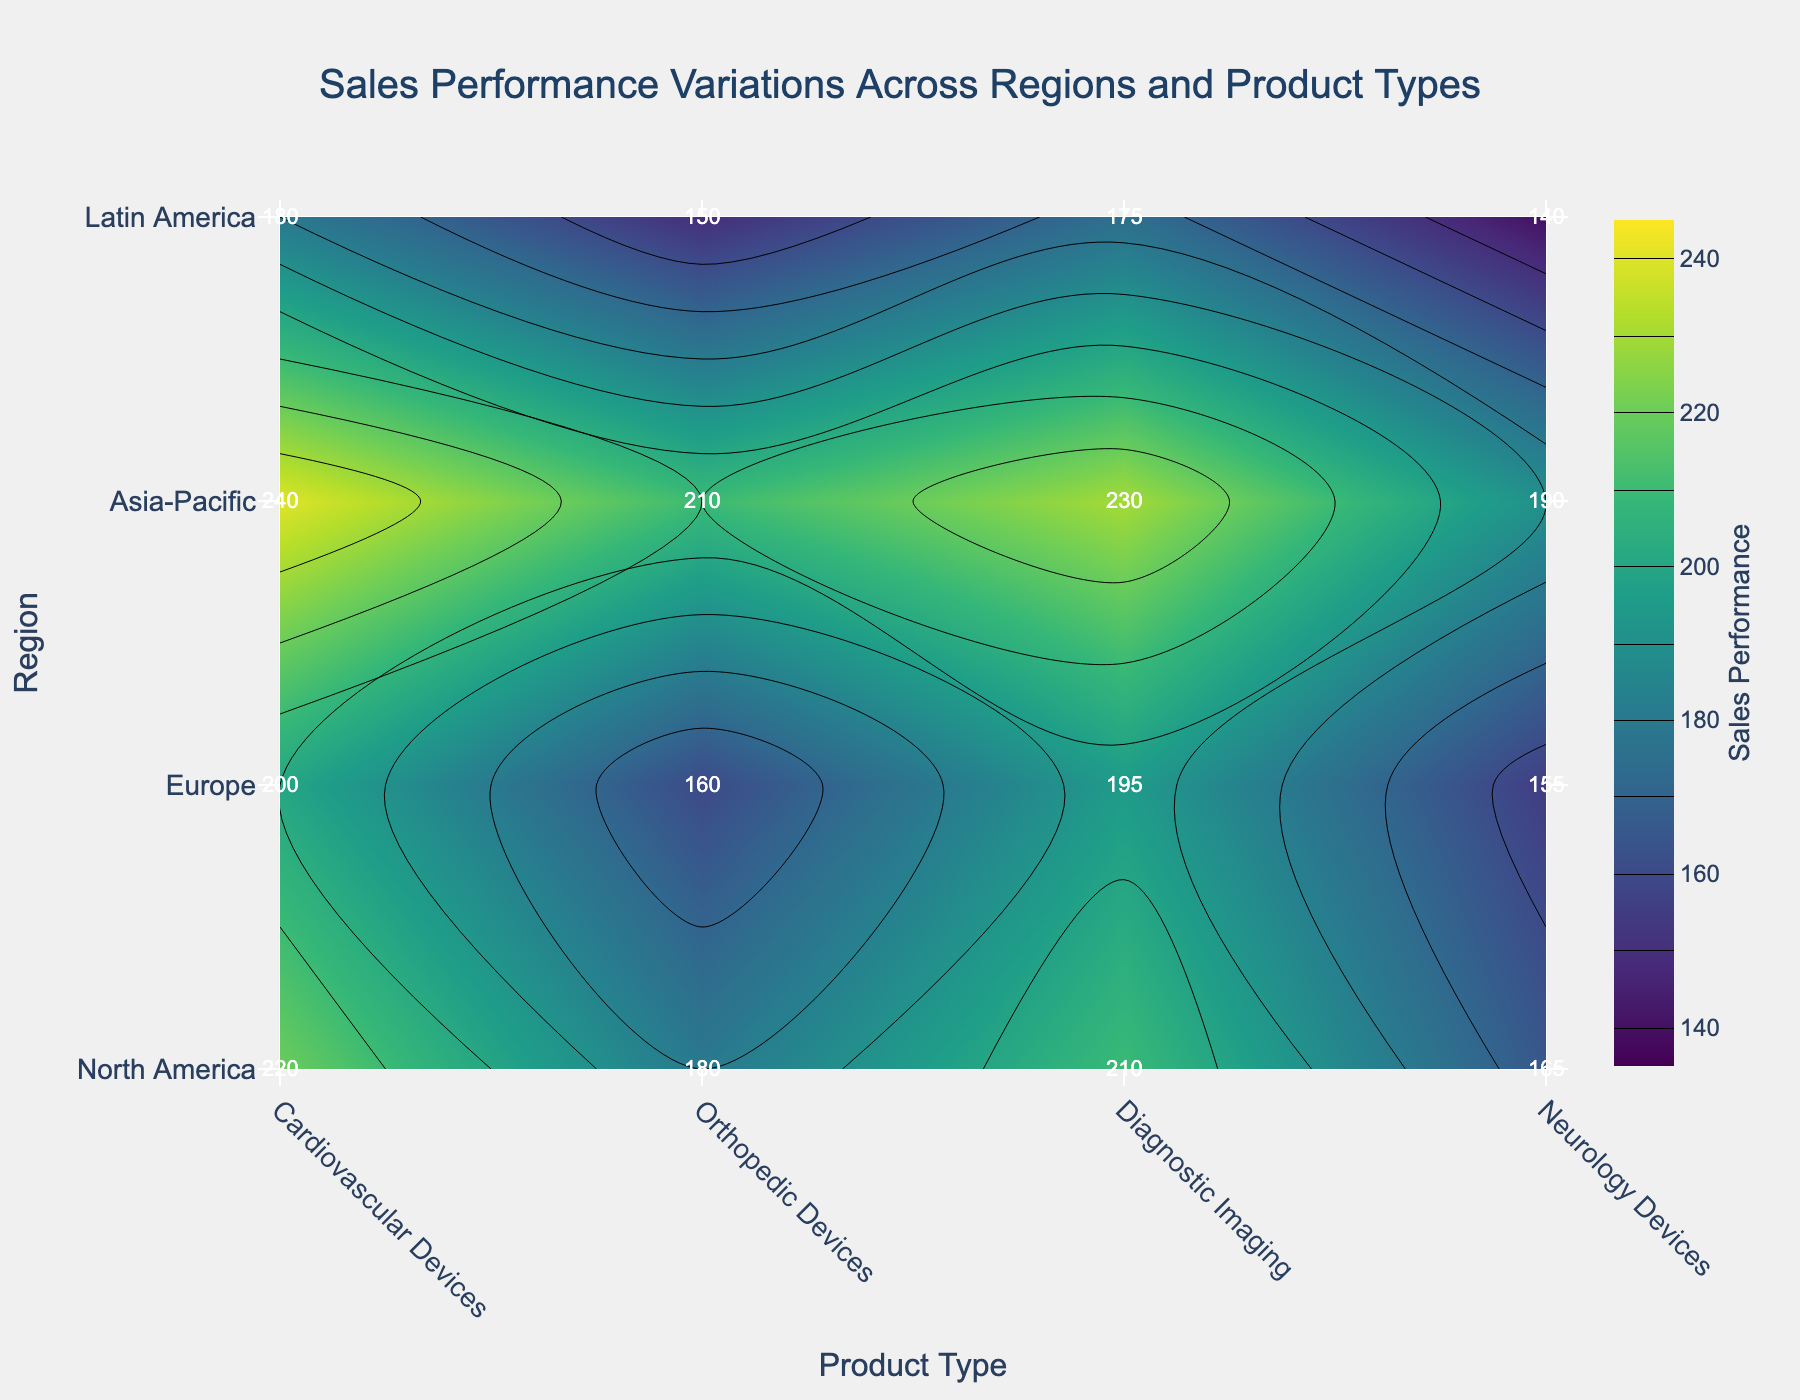What's the title of the figure? The title is usually displayed at the top of the plot. In this case, it's clearly shown as 'Sales Performance Variations Across Regions and Product Types'.
Answer: Sales Performance Variations Across Regions and Product Types Which product type in Asia-Pacific has the highest sales performance? Look for the region 'Asia-Pacific' on the y-axis and identify the product type with the highest value in that row. 'Cardiovascular Devices' shows a sales performance of 240, which is the highest in the 'Asia-Pacific' row.
Answer: Cardiovascular Devices What's the difference in sales performance between Neurology Devices in North America and Diagnostic Imaging in Europe? Identify the sales performance values: 'Neurology Devices' in 'North America' is 165 and 'Diagnostic Imaging' in 'Europe' is 195. The difference is 195 - 165.
Answer: 30 How many regions are evaluated in the figure? Count the number of unique entries in the 'Region' axis on the figure. The regions are 'North America', 'Europe', 'Asia-Pacific', and 'Latin America'.
Answer: 4 Which product type has the lowest sales performance in Latin America? Look for the region 'Latin America' and check the sales performance values for the product types in that row. 'Neurology Devices' has the lowest sales performance with a value of 140.
Answer: Neurology Devices What's the average sales performance of all product types in Europe? Sum the sales performance values for 'Europe' and divide by the number of product types (4). (200 + 160 + 195 + 155) / 4.
Answer: 177.5 What is the range of sales performance values in the figure? Find the minimum and maximum sales performance values. The minimum value is 140 and the maximum is 240. The range is 240 - 140.
Answer: 100 Which region has the highest overall sales performance? Sum the sales performance values for each region and compare. North America: 220 + 180 + 210 + 165 = 775, Asia-Pacific: 240 + 210 + 230 + 190 = 870, Europe: 200 + 160 + 195 + 155 = 710, Latin America: 180 + 150 + 175 + 140 = 645. The highest sum is for Asia-Pacific.
Answer: Asia-Pacific Do Cardiovascular Devices have higher sales performance in North America or Europe? By how much? Check the sales performance for 'Cardiovascular Devices' in 'North America' and 'Europe'. North America: 220, Europe: 200. Calculate the difference, 220 - 200.
Answer: North America by 20 What's the lowest sales performance value among all product types in all regions? Identify the lowest value across the entire figure, which is 140 for 'Neurology Devices' in 'Latin America'.
Answer: 140 